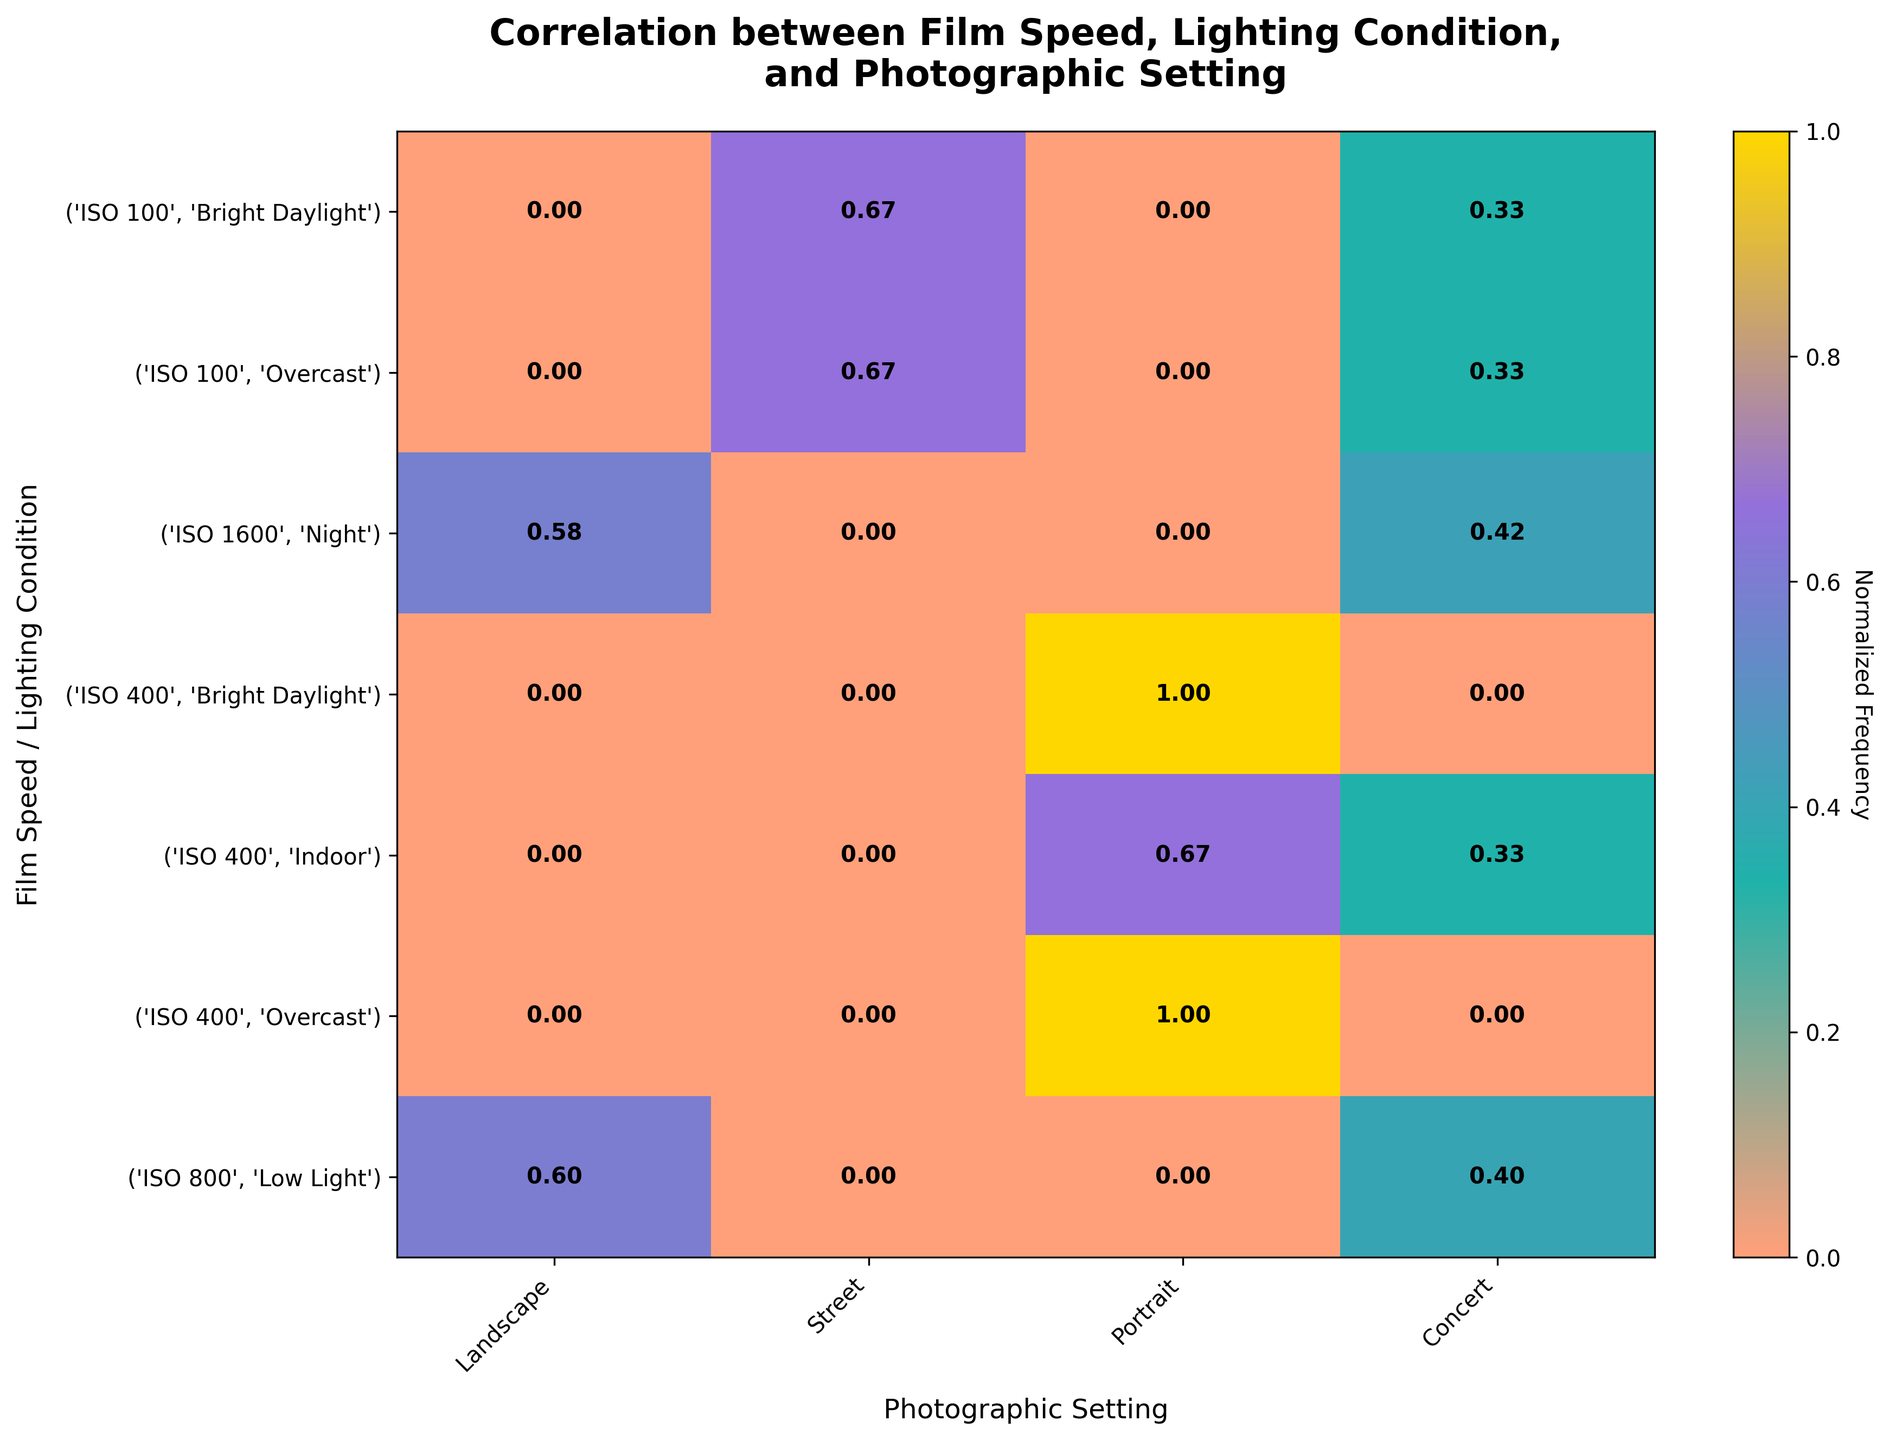Which film speed and lighting combination is most frequently used for indoor portrait photography? We look for the highest normalized frequency in the row corresponding to indoor portraits. ISO 400 in Indoor lighting has the highest frequency
Answer: ISO 400, Indoor What lighting condition is most commonly associated with ISO 100 for landscape photography? Check the normalized frequency for landscape under ISO 100 for each lighting condition. Bright Daylight has the highest normalized frequency for ISO 100 in landscapes
Answer: Bright Daylight How does the usage of ISO 800 compare between low light street and concert settings? Compare the normalized frequencies for ISO 800 in low light for both street and concert settings. Concert has a higher normalized frequency than street for ISO 800
Answer: Concert has higher usage Which film speed has the most even distribution across different lighting conditions? Examine the uniformity of the normalized frequencies across different lighting conditions for each film speed. ISO 100 shows a more even distribution
Answer: ISO 100 For ISO 1600, which photographic setting has the highest frequency under night lighting conditions? Check the normalized frequencies for ISO 1600 under night lighting conditions for each photographic setting. Concert has a higher normalized frequency than street for ISO 1600 under night lighting
Answer: Concert What is the primary photographic setting for ISO 400 in bright daylight conditions? Identify the photographic setting with the highest normalized frequency for ISO 400 under bright daylight conditions. Portrait has the highest frequency
Answer: Portrait Compare the usage of ISO 400 in portrait photography across all lighting conditions. Which lighting condition is most frequent? Compare the normalized frequencies of portrait settings for ISO 400 across different lighting conditions. Indoor has the highest normalized frequency for ISO 400 in portrait settings
Answer: Indoor In which photographic setting is ISO 800 least used under low light conditions? Check the normalized frequencies for ISO 800 under low light conditions for each photographic setting and find the lowest value. Street has a lower normalized frequency than concert for ISO 800 under low light
Answer: Street 